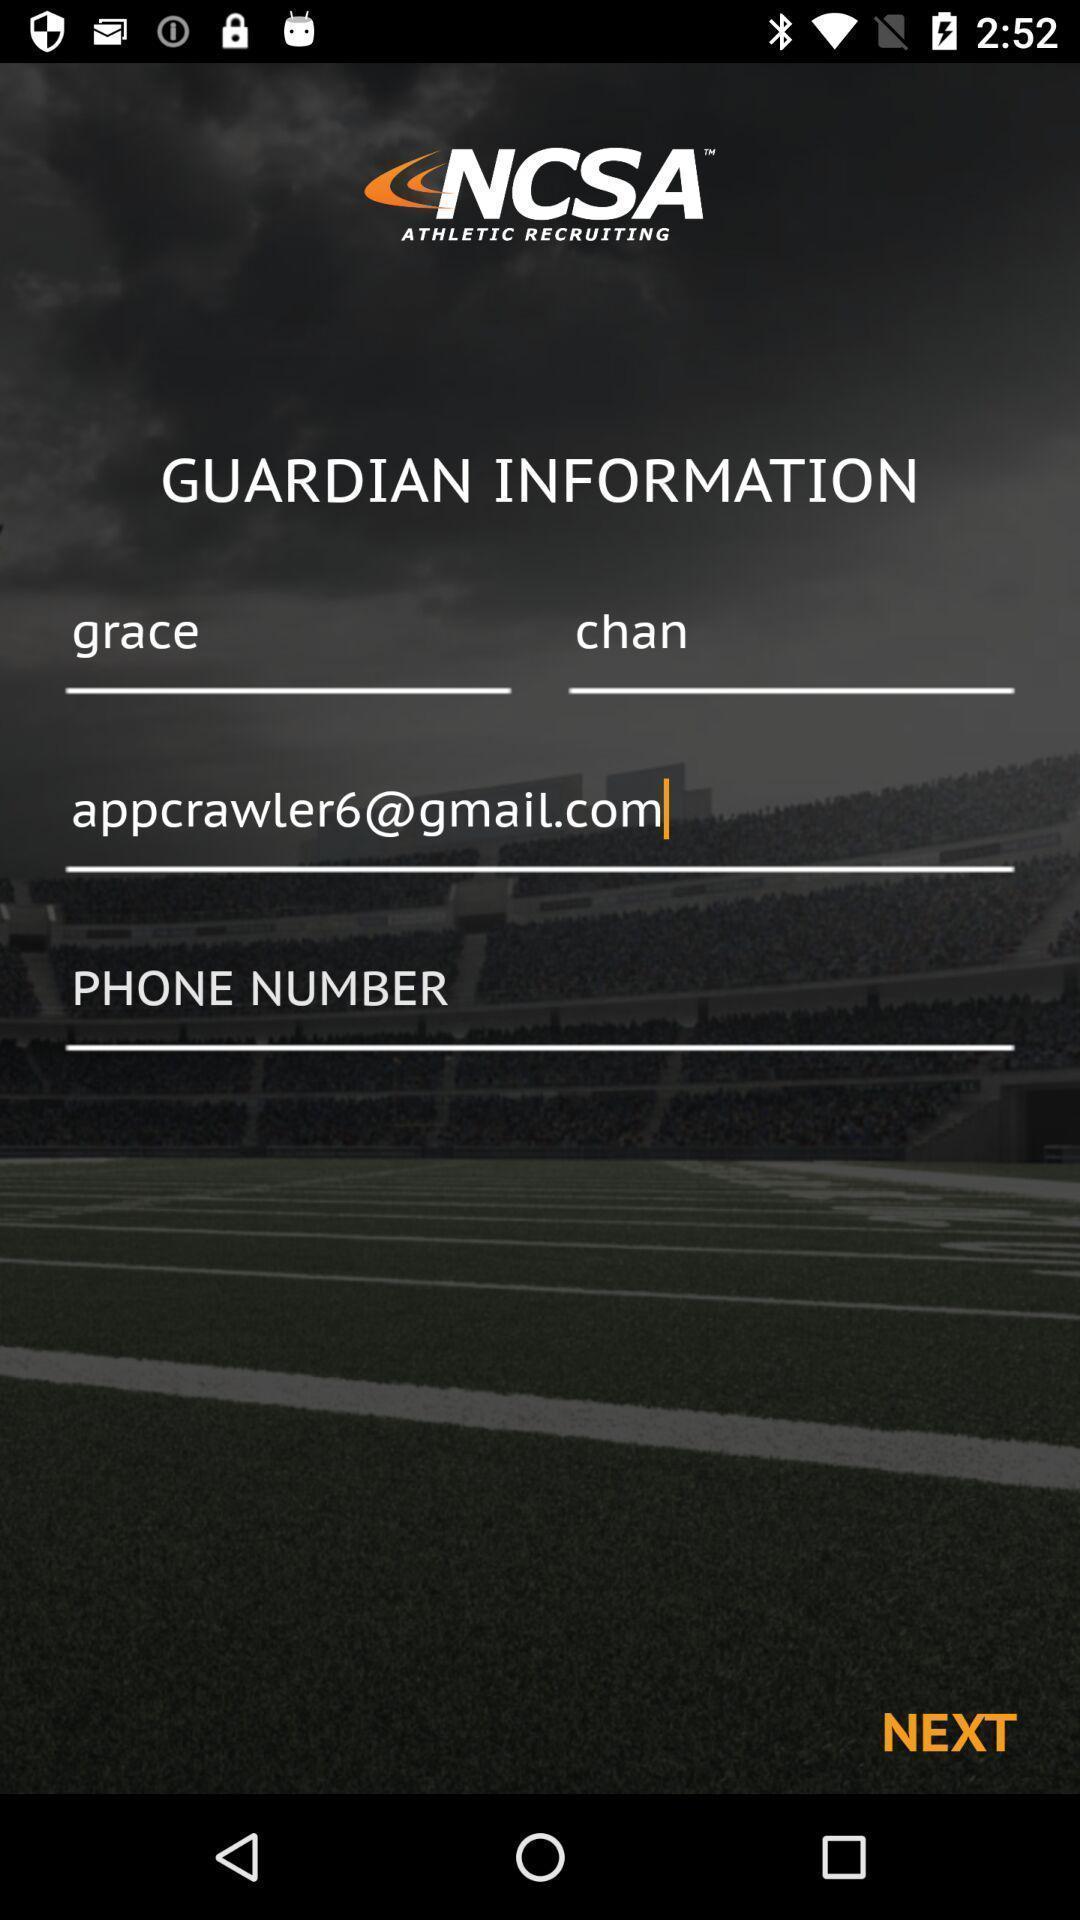Describe the key features of this screenshot. Page displaying to enter details. 